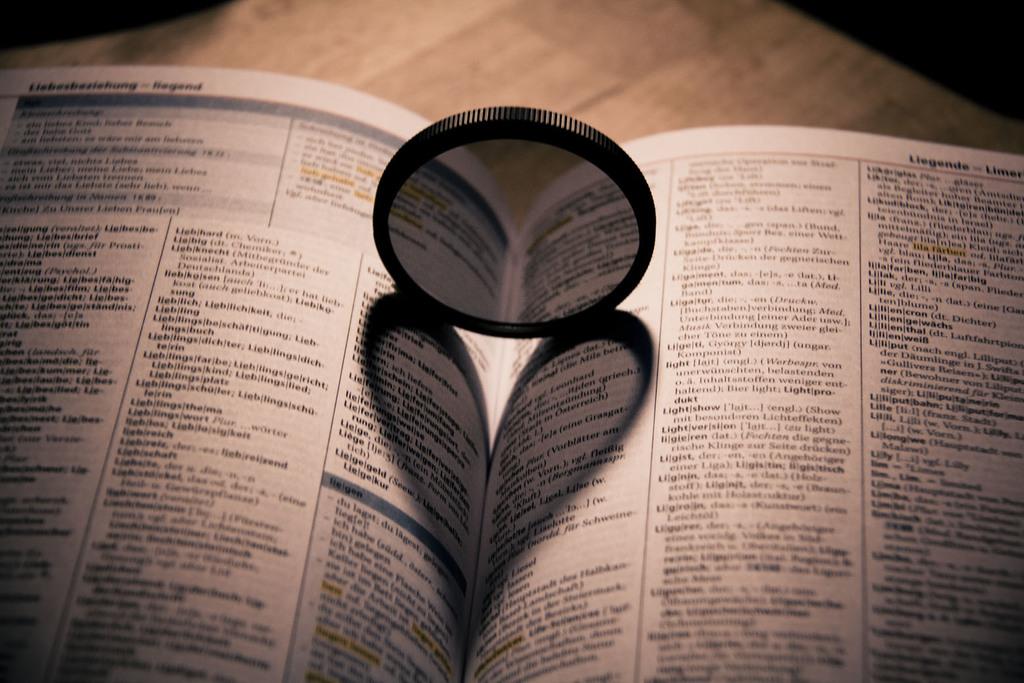According to the header, what is the first word on the page on the right?
Ensure brevity in your answer.  Liegende. 